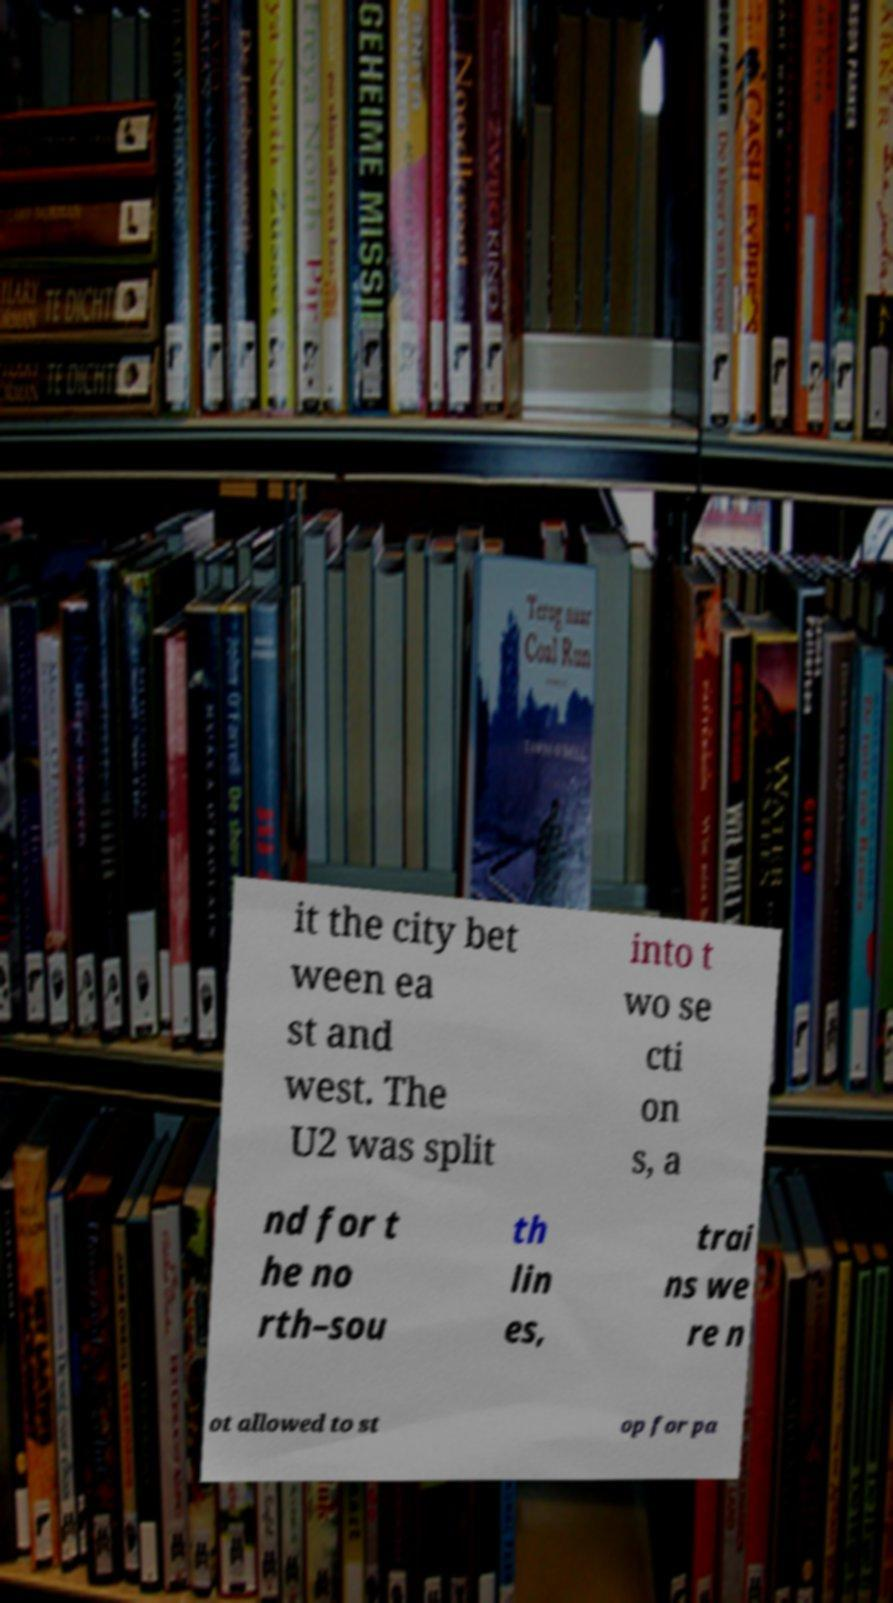Can you read and provide the text displayed in the image?This photo seems to have some interesting text. Can you extract and type it out for me? it the city bet ween ea st and west. The U2 was split into t wo se cti on s, a nd for t he no rth–sou th lin es, trai ns we re n ot allowed to st op for pa 